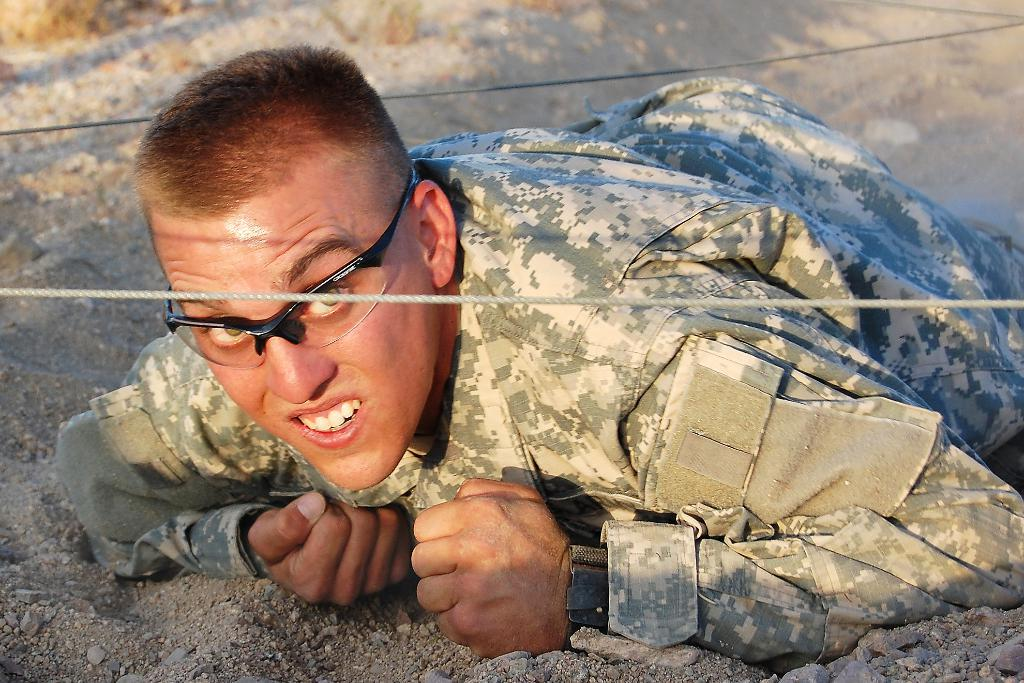What is the person in the image wearing? The person is wearing a military uniform. What is the person's position in the image? The person is lying on the sand. What is the person doing in the image? The person is watching something. What other objects can be seen in the image? There are ropes visible in the image. What type of crime is being committed in the image? There is no indication of a crime being committed in the image. What is the person using to eat the soup in the image? There is no soup or spoon present in the image. 